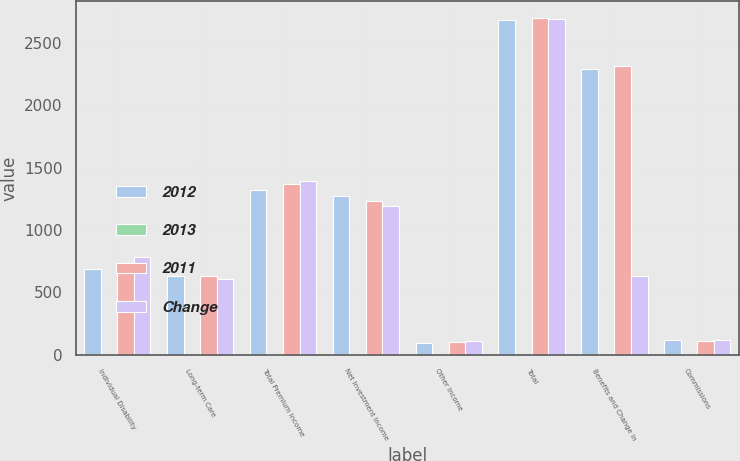Convert chart. <chart><loc_0><loc_0><loc_500><loc_500><stacked_bar_chart><ecel><fcel>Individual Disability<fcel>Long-term Care<fcel>Total Premium Income<fcel>Net Investment Income<fcel>Other Income<fcel>Total<fcel>Benefits and Change in<fcel>Commissions<nl><fcel>2012<fcel>687.5<fcel>630.6<fcel>1318.8<fcel>1272.3<fcel>93.9<fcel>2685<fcel>2293<fcel>113.8<nl><fcel>2013<fcel>6.6<fcel>0.2<fcel>3.8<fcel>3.4<fcel>6.2<fcel>0.6<fcel>0.9<fcel>1.1<nl><fcel>2011<fcel>736.4<fcel>631.9<fcel>1370.5<fcel>1230.5<fcel>100.1<fcel>2701.1<fcel>2314.9<fcel>112.6<nl><fcel>Change<fcel>787<fcel>608.1<fcel>1395.3<fcel>1189.7<fcel>106.1<fcel>2691.1<fcel>630.6<fcel>113.6<nl></chart> 